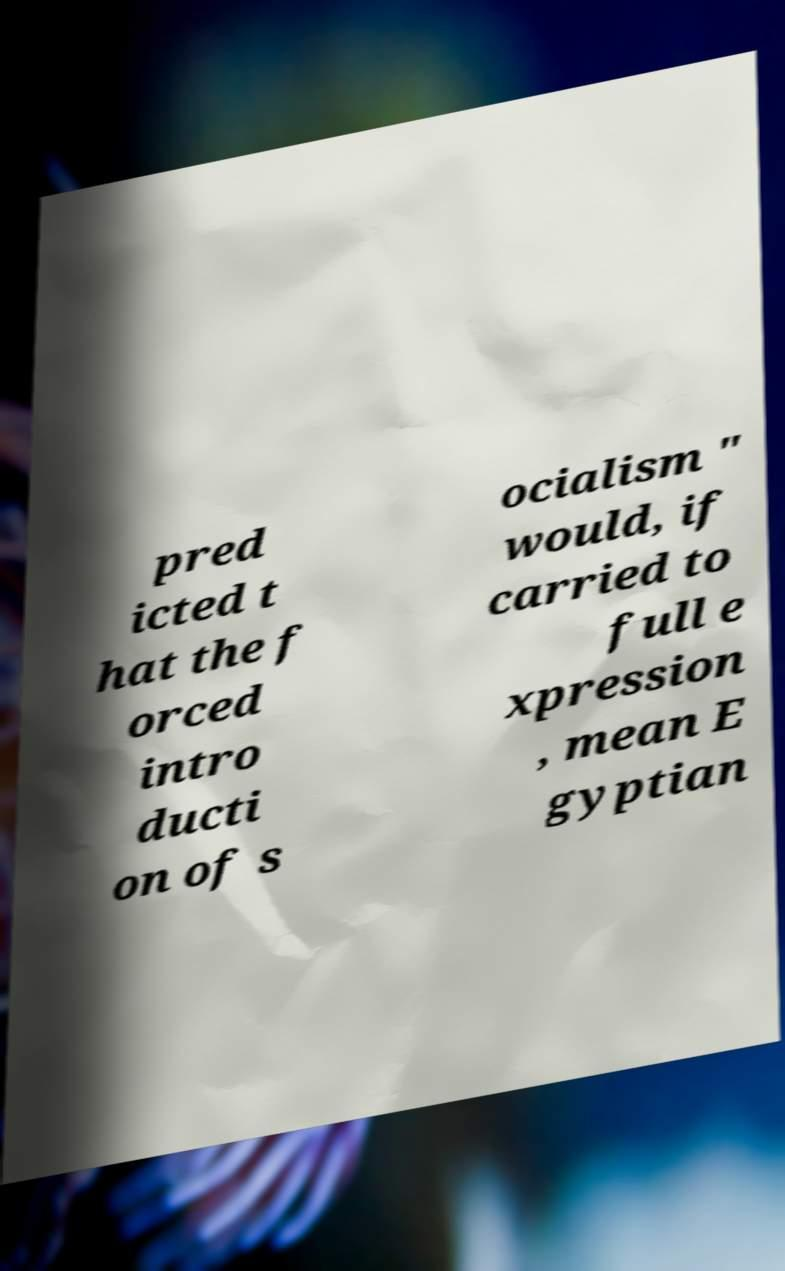There's text embedded in this image that I need extracted. Can you transcribe it verbatim? pred icted t hat the f orced intro ducti on of s ocialism " would, if carried to full e xpression , mean E gyptian 